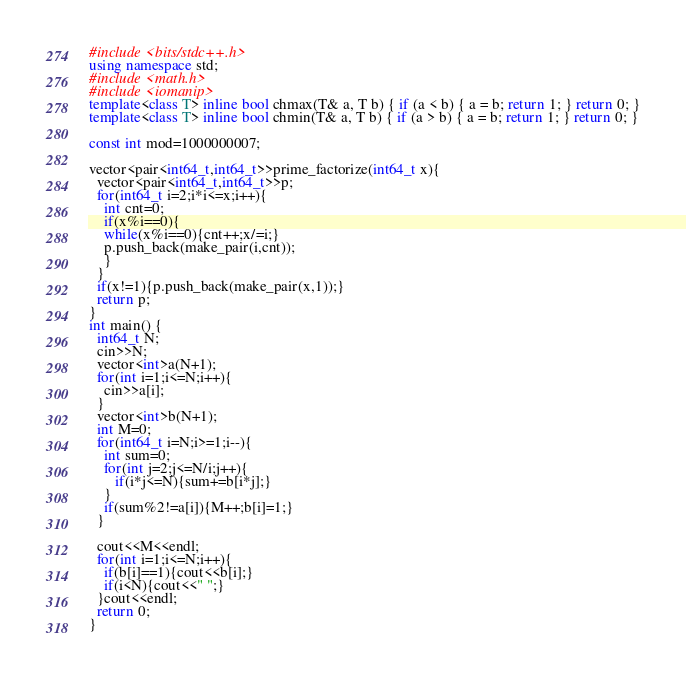Convert code to text. <code><loc_0><loc_0><loc_500><loc_500><_C++_>#include <bits/stdc++.h>
using namespace std;
#include <math.h>
#include <iomanip>
template<class T> inline bool chmax(T& a, T b) { if (a < b) { a = b; return 1; } return 0; }
template<class T> inline bool chmin(T& a, T b) { if (a > b) { a = b; return 1; } return 0; }

const int mod=1000000007;

vector<pair<int64_t,int64_t>>prime_factorize(int64_t x){
  vector<pair<int64_t,int64_t>>p;
  for(int64_t i=2;i*i<=x;i++){
    int cnt=0;
    if(x%i==0){
    while(x%i==0){cnt++;x/=i;}
    p.push_back(make_pair(i,cnt));
    }
  }
  if(x!=1){p.push_back(make_pair(x,1));}
  return p; 
}
int main() {
  int64_t N;
  cin>>N;
  vector<int>a(N+1);
  for(int i=1;i<=N;i++){
    cin>>a[i];
  }
  vector<int>b(N+1);
  int M=0;
  for(int64_t i=N;i>=1;i--){
    int sum=0;
    for(int j=2;j<=N/i;j++){
       if(i*j<=N){sum+=b[i*j];}
    }
    if(sum%2!=a[i]){M++;b[i]=1;}
  }

  cout<<M<<endl;
  for(int i=1;i<=N;i++){
    if(b[i]==1){cout<<b[i];}
    if(i<N){cout<<" ";}
  }cout<<endl;
  return 0;
}</code> 